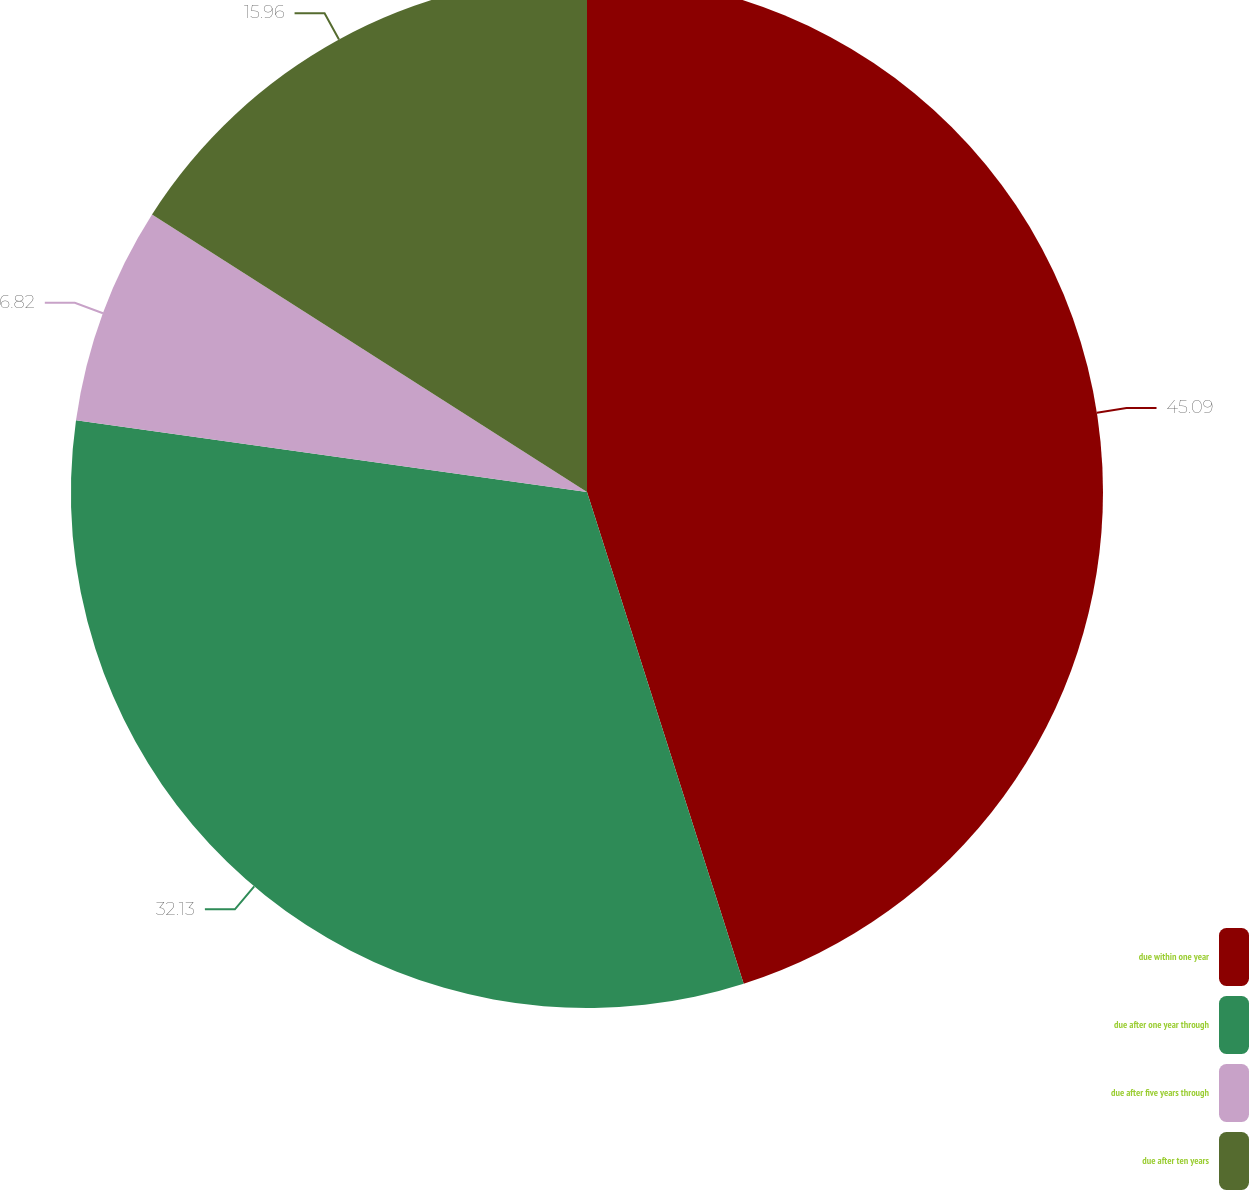Convert chart to OTSL. <chart><loc_0><loc_0><loc_500><loc_500><pie_chart><fcel>due within one year<fcel>due after one year through<fcel>due after five years through<fcel>due after ten years<nl><fcel>45.09%<fcel>32.13%<fcel>6.82%<fcel>15.96%<nl></chart> 